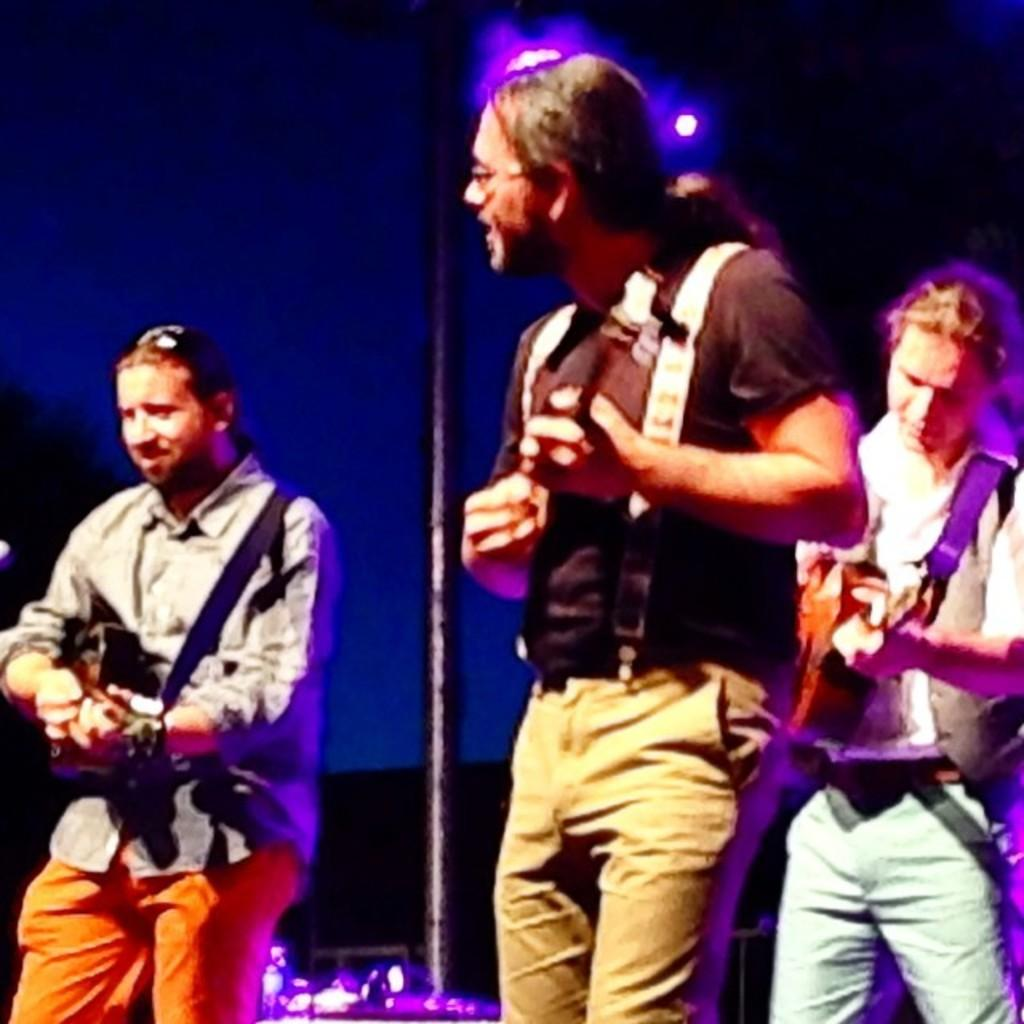What are the people in the image doing? The people in the image are musicians, and they are standing and performing. Can you describe the musicians' surroundings? In the background of the image, there is a black pole and lights. What color is the pole in the image? The pole in the image is black in color. What else can be seen in the background of the image? There are lights in the background of the image. Can you tell me how many waves are visible in the image? There are no waves present in the image; it features musicians performing with a black pole and lights in the background. What type of popcorn is being served in the image? There is no popcorn present in the image. 